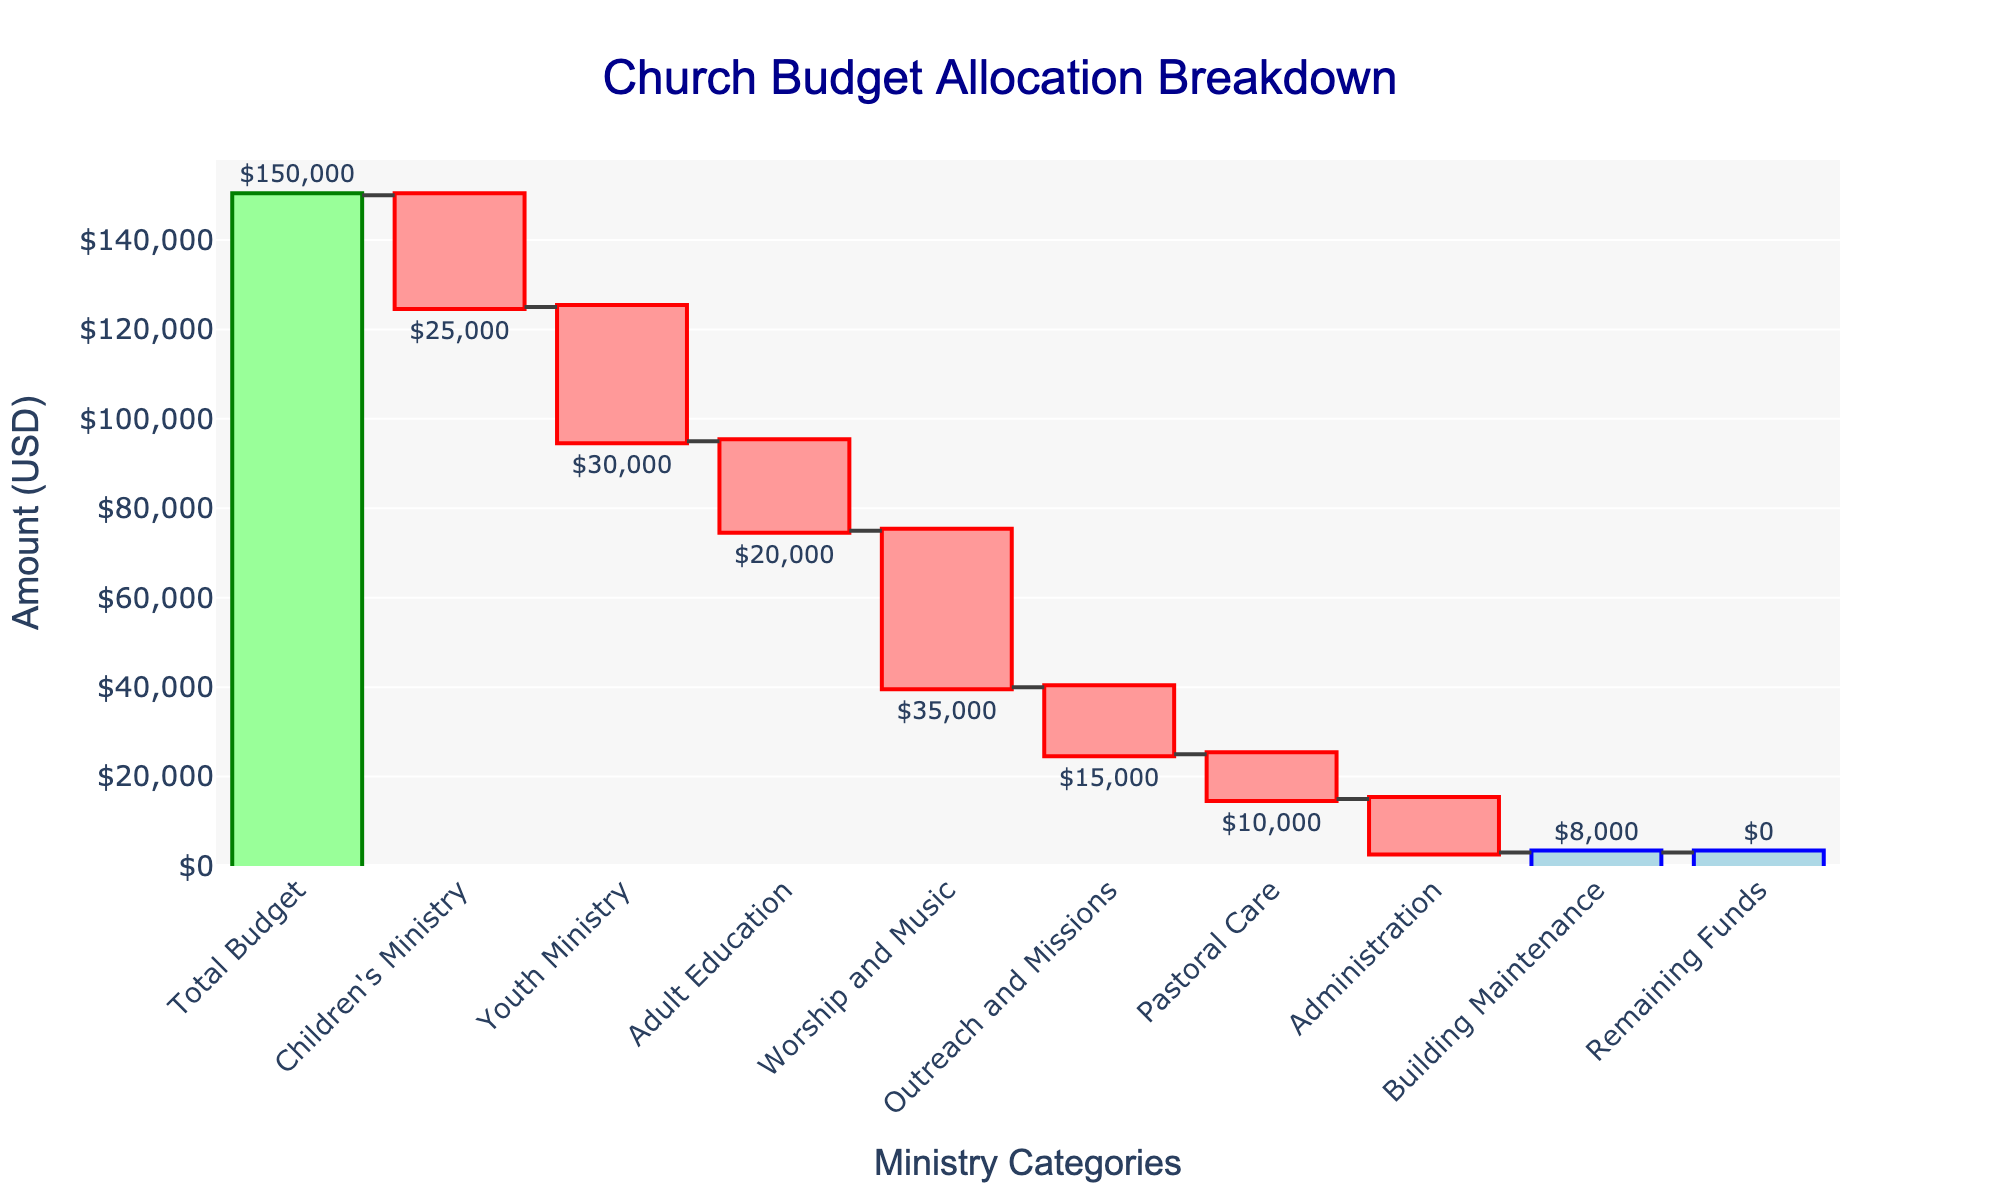Which ministry has the highest allocation? Looking at the waterfall chart, identify the largest negative bar which represents the highest allocation. The "Worship and Music" ministry has the highest allocation at $35,000.
Answer: "Worship and Music" How much is allocated to the Youth Ministry? Find the specific category "Youth Ministry" on the x-axis and refer to the corresponding vertical bar. The allocation is $30,000.
Answer: $30,000 What is the total budget before allocations? The starting point of the waterfall chart, labeled as "Total Budget," shows the amount before any allocations. It is $150,000.
Answer: $150,000 How much money remains after all allocations? The last bar in the waterfall chart, labeled "Remaining Funds," shows the amount left after all allocations. It is $0.
Answer: $0 Which category has an allocation closest to $10,000? Identify the vertical bars and their corresponding values. The "Pastoral Care" ministry has an allocation of $10,000, which matches exactly.
Answer: "Pastoral Care" How does the allocation for Adult Education compare to Children's Ministry? Locate the bars for both ministries on the x-axis and compare their heights. The "Adult Education" ministry is allocated $20,000, whereas "Children's Ministry" is allocated $25,000. So, Adult Education is $5,000 less than Children's Ministry.
Answer: Adult Education is $5,000 less Sum the allocations for Youth Ministry and Administration. Find the heights of the two bars labeled "Youth Ministry" ($30,000) and "Administration" ($12,000) and add them together. $30,000 + $12,000 = $42,000.
Answer: $42,000 What is the combined allocation for Outreach and Missions and Building Maintenance? Locate the corresponding bars and add the values for "Outreach and Missions" ($15,000) and "Building Maintenance" ($8,000). $15,000 + $8,000 = $23,000.
Answer: $23,000 Is the allocation for Administration higher or lower than for Pastoral Care? Compare the bars for "Administration" and "Pastoral Care" on the x-axis. "Administration" ($12,000) is higher than "Pastoral Care" ($10,000).
Answer: Higher What is the difference between the allocations for Worship and Music and Building Maintenance? Find the heights of the bars for each category. "Worship and Music" has $35,000, and "Building Maintenance" has $8,000. $35,000 - $8,000 = $27,000.
Answer: $27,000 